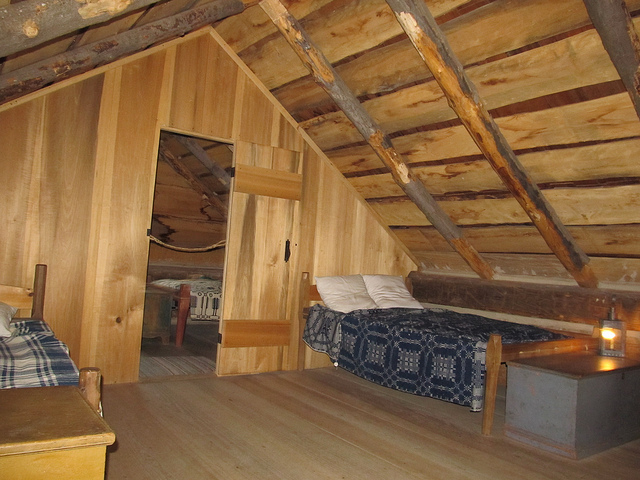Is there any indication of modern amenities in the room? From the visible elements in the photograph, the room maintains a traditional, possibly historical aesthetic with no clear indication of modern amenities. There's a sense of stepping back in time without the presence of contemporary conveniences such as electronic gadgets or appliances. 